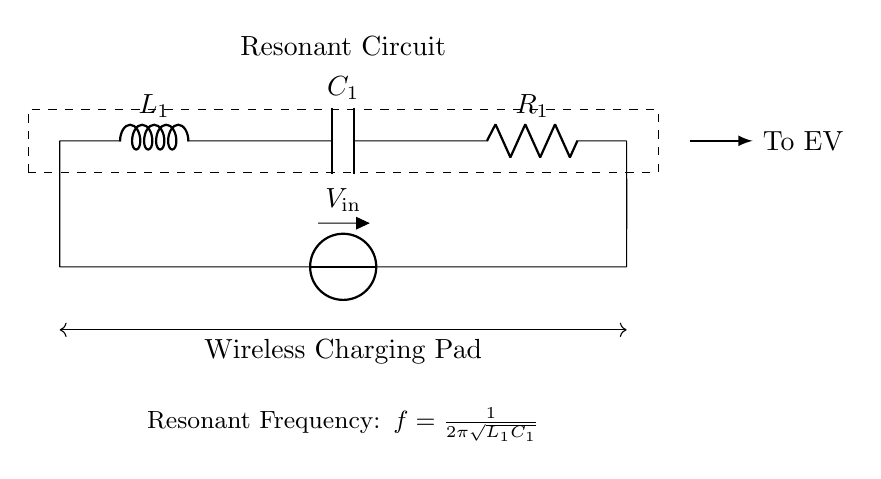What components are in this circuit? The circuit consists of an inductor labeled L1, a capacitor labeled C1, and a resistor labeled R1. These components are standard in resonant circuits used for applications like wireless charging.
Answer: Inductor, Capacitor, Resistor What is the purpose of the voltage source in this circuit? The voltage source labeled V_in provides the necessary input voltage for the resonant circuit to operate, powering the components. Its role is to initiate energy flow in the circuit for wireless charging.
Answer: Input voltage What is the resonant frequency formula depicted? The formula given in the circuit is f = 1/(2π√(L1C1)), which calculates the resonant frequency of the circuit based on the values of L1 and C1. This frequency is crucial as it determines the operating condition of the wireless charging pad.
Answer: f = 1/(2π√(L1C1)) Why is this circuit called a resonant circuit? It is termed a resonant circuit because it uses the natural frequency of oscillation that occurs due to the interplay between the inductor and capacitor. This resonance allows for efficient energy transfer, essential in wireless charging applications.
Answer: Due to the energy exchange between L and C What will happen if the values of L1 and C1 are not balanced? If L1 and C1 are not properly matched to achieve the desired resonant frequency, the circuit may not operate efficiently, causing issues such as reduced power transfer, heating, or even failure to charge effectively. This imbalance can significantly affect the performance of the wireless charging pad.
Answer: Inefficient operation 